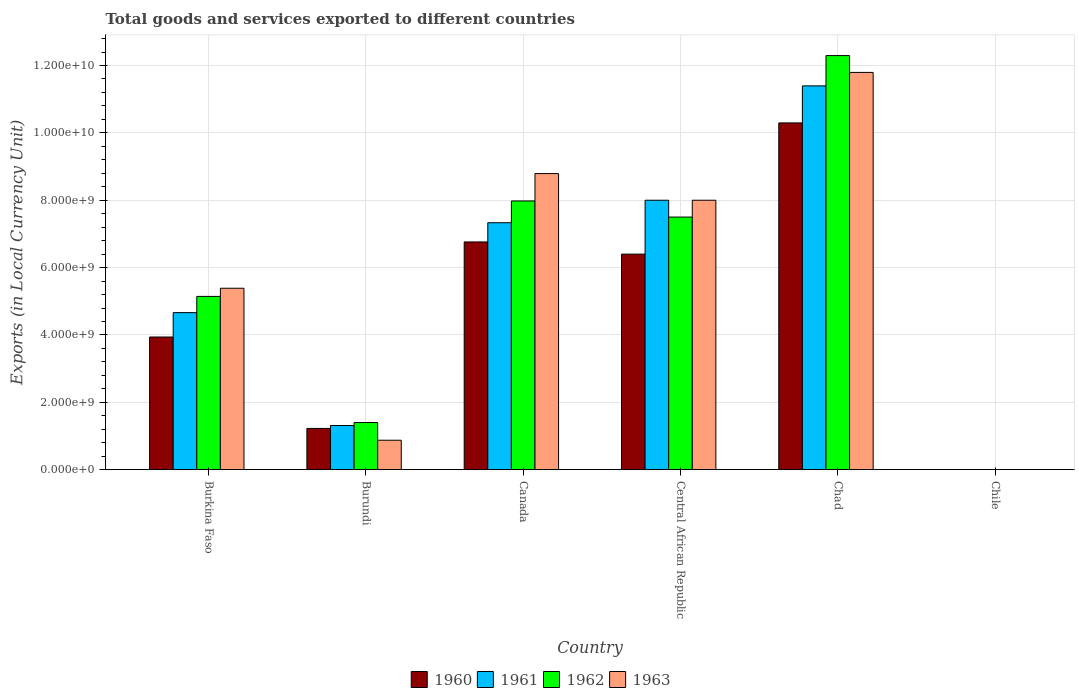How many groups of bars are there?
Provide a short and direct response. 6. Are the number of bars per tick equal to the number of legend labels?
Give a very brief answer. Yes. How many bars are there on the 1st tick from the left?
Offer a terse response. 4. What is the label of the 4th group of bars from the left?
Provide a succinct answer. Central African Republic. What is the Amount of goods and services exports in 1960 in Burundi?
Ensure brevity in your answer.  1.22e+09. Across all countries, what is the maximum Amount of goods and services exports in 1961?
Offer a very short reply. 1.14e+1. Across all countries, what is the minimum Amount of goods and services exports in 1962?
Your response must be concise. 7.00e+05. In which country was the Amount of goods and services exports in 1961 maximum?
Keep it short and to the point. Chad. What is the total Amount of goods and services exports in 1961 in the graph?
Offer a very short reply. 3.27e+1. What is the difference between the Amount of goods and services exports in 1963 in Burundi and that in Chad?
Your answer should be very brief. -1.09e+1. What is the difference between the Amount of goods and services exports in 1963 in Burkina Faso and the Amount of goods and services exports in 1961 in Central African Republic?
Offer a very short reply. -2.61e+09. What is the average Amount of goods and services exports in 1962 per country?
Your answer should be very brief. 5.72e+09. What is the difference between the Amount of goods and services exports of/in 1961 and Amount of goods and services exports of/in 1963 in Canada?
Offer a very short reply. -1.46e+09. What is the ratio of the Amount of goods and services exports in 1962 in Burundi to that in Central African Republic?
Make the answer very short. 0.19. Is the Amount of goods and services exports in 1963 in Central African Republic less than that in Chad?
Offer a terse response. Yes. Is the difference between the Amount of goods and services exports in 1961 in Burkina Faso and Burundi greater than the difference between the Amount of goods and services exports in 1963 in Burkina Faso and Burundi?
Give a very brief answer. No. What is the difference between the highest and the second highest Amount of goods and services exports in 1962?
Provide a short and direct response. 4.32e+09. What is the difference between the highest and the lowest Amount of goods and services exports in 1960?
Ensure brevity in your answer.  1.03e+1. In how many countries, is the Amount of goods and services exports in 1962 greater than the average Amount of goods and services exports in 1962 taken over all countries?
Provide a short and direct response. 3. What does the 3rd bar from the left in Canada represents?
Provide a succinct answer. 1962. Are all the bars in the graph horizontal?
Your answer should be compact. No. Are the values on the major ticks of Y-axis written in scientific E-notation?
Offer a very short reply. Yes. Does the graph contain any zero values?
Your answer should be very brief. No. Does the graph contain grids?
Your answer should be very brief. Yes. How are the legend labels stacked?
Make the answer very short. Horizontal. What is the title of the graph?
Make the answer very short. Total goods and services exported to different countries. Does "2003" appear as one of the legend labels in the graph?
Your answer should be very brief. No. What is the label or title of the X-axis?
Ensure brevity in your answer.  Country. What is the label or title of the Y-axis?
Offer a terse response. Exports (in Local Currency Unit). What is the Exports (in Local Currency Unit) in 1960 in Burkina Faso?
Offer a very short reply. 3.94e+09. What is the Exports (in Local Currency Unit) in 1961 in Burkina Faso?
Offer a terse response. 4.66e+09. What is the Exports (in Local Currency Unit) of 1962 in Burkina Faso?
Ensure brevity in your answer.  5.14e+09. What is the Exports (in Local Currency Unit) of 1963 in Burkina Faso?
Provide a succinct answer. 5.39e+09. What is the Exports (in Local Currency Unit) in 1960 in Burundi?
Provide a short and direct response. 1.22e+09. What is the Exports (in Local Currency Unit) of 1961 in Burundi?
Make the answer very short. 1.31e+09. What is the Exports (in Local Currency Unit) in 1962 in Burundi?
Offer a very short reply. 1.40e+09. What is the Exports (in Local Currency Unit) of 1963 in Burundi?
Provide a short and direct response. 8.75e+08. What is the Exports (in Local Currency Unit) in 1960 in Canada?
Your answer should be compact. 6.76e+09. What is the Exports (in Local Currency Unit) in 1961 in Canada?
Offer a very short reply. 7.33e+09. What is the Exports (in Local Currency Unit) in 1962 in Canada?
Your answer should be very brief. 7.98e+09. What is the Exports (in Local Currency Unit) of 1963 in Canada?
Give a very brief answer. 8.79e+09. What is the Exports (in Local Currency Unit) in 1960 in Central African Republic?
Ensure brevity in your answer.  6.40e+09. What is the Exports (in Local Currency Unit) in 1961 in Central African Republic?
Provide a succinct answer. 8.00e+09. What is the Exports (in Local Currency Unit) of 1962 in Central African Republic?
Your answer should be very brief. 7.50e+09. What is the Exports (in Local Currency Unit) in 1963 in Central African Republic?
Offer a terse response. 8.00e+09. What is the Exports (in Local Currency Unit) of 1960 in Chad?
Your answer should be very brief. 1.03e+1. What is the Exports (in Local Currency Unit) of 1961 in Chad?
Ensure brevity in your answer.  1.14e+1. What is the Exports (in Local Currency Unit) in 1962 in Chad?
Ensure brevity in your answer.  1.23e+1. What is the Exports (in Local Currency Unit) in 1963 in Chad?
Your response must be concise. 1.18e+1. What is the Exports (in Local Currency Unit) in 1961 in Chile?
Your answer should be very brief. 6.00e+05. What is the Exports (in Local Currency Unit) in 1962 in Chile?
Make the answer very short. 7.00e+05. What is the Exports (in Local Currency Unit) in 1963 in Chile?
Your answer should be compact. 1.10e+06. Across all countries, what is the maximum Exports (in Local Currency Unit) in 1960?
Ensure brevity in your answer.  1.03e+1. Across all countries, what is the maximum Exports (in Local Currency Unit) of 1961?
Ensure brevity in your answer.  1.14e+1. Across all countries, what is the maximum Exports (in Local Currency Unit) in 1962?
Offer a terse response. 1.23e+1. Across all countries, what is the maximum Exports (in Local Currency Unit) of 1963?
Offer a terse response. 1.18e+1. Across all countries, what is the minimum Exports (in Local Currency Unit) of 1960?
Give a very brief answer. 6.00e+05. Across all countries, what is the minimum Exports (in Local Currency Unit) in 1962?
Your answer should be very brief. 7.00e+05. Across all countries, what is the minimum Exports (in Local Currency Unit) of 1963?
Your answer should be compact. 1.10e+06. What is the total Exports (in Local Currency Unit) of 1960 in the graph?
Make the answer very short. 2.86e+1. What is the total Exports (in Local Currency Unit) of 1961 in the graph?
Give a very brief answer. 3.27e+1. What is the total Exports (in Local Currency Unit) in 1962 in the graph?
Keep it short and to the point. 3.43e+1. What is the total Exports (in Local Currency Unit) of 1963 in the graph?
Offer a terse response. 3.48e+1. What is the difference between the Exports (in Local Currency Unit) in 1960 in Burkina Faso and that in Burundi?
Give a very brief answer. 2.71e+09. What is the difference between the Exports (in Local Currency Unit) in 1961 in Burkina Faso and that in Burundi?
Ensure brevity in your answer.  3.35e+09. What is the difference between the Exports (in Local Currency Unit) in 1962 in Burkina Faso and that in Burundi?
Your response must be concise. 3.74e+09. What is the difference between the Exports (in Local Currency Unit) of 1963 in Burkina Faso and that in Burundi?
Your answer should be compact. 4.51e+09. What is the difference between the Exports (in Local Currency Unit) of 1960 in Burkina Faso and that in Canada?
Make the answer very short. -2.82e+09. What is the difference between the Exports (in Local Currency Unit) of 1961 in Burkina Faso and that in Canada?
Make the answer very short. -2.67e+09. What is the difference between the Exports (in Local Currency Unit) of 1962 in Burkina Faso and that in Canada?
Make the answer very short. -2.83e+09. What is the difference between the Exports (in Local Currency Unit) in 1963 in Burkina Faso and that in Canada?
Ensure brevity in your answer.  -3.40e+09. What is the difference between the Exports (in Local Currency Unit) in 1960 in Burkina Faso and that in Central African Republic?
Make the answer very short. -2.46e+09. What is the difference between the Exports (in Local Currency Unit) of 1961 in Burkina Faso and that in Central African Republic?
Your response must be concise. -3.34e+09. What is the difference between the Exports (in Local Currency Unit) of 1962 in Burkina Faso and that in Central African Republic?
Keep it short and to the point. -2.36e+09. What is the difference between the Exports (in Local Currency Unit) of 1963 in Burkina Faso and that in Central African Republic?
Your answer should be very brief. -2.61e+09. What is the difference between the Exports (in Local Currency Unit) in 1960 in Burkina Faso and that in Chad?
Your response must be concise. -6.36e+09. What is the difference between the Exports (in Local Currency Unit) in 1961 in Burkina Faso and that in Chad?
Provide a short and direct response. -6.73e+09. What is the difference between the Exports (in Local Currency Unit) in 1962 in Burkina Faso and that in Chad?
Your answer should be compact. -7.15e+09. What is the difference between the Exports (in Local Currency Unit) of 1963 in Burkina Faso and that in Chad?
Give a very brief answer. -6.41e+09. What is the difference between the Exports (in Local Currency Unit) of 1960 in Burkina Faso and that in Chile?
Offer a terse response. 3.94e+09. What is the difference between the Exports (in Local Currency Unit) in 1961 in Burkina Faso and that in Chile?
Provide a short and direct response. 4.66e+09. What is the difference between the Exports (in Local Currency Unit) in 1962 in Burkina Faso and that in Chile?
Offer a terse response. 5.14e+09. What is the difference between the Exports (in Local Currency Unit) of 1963 in Burkina Faso and that in Chile?
Give a very brief answer. 5.39e+09. What is the difference between the Exports (in Local Currency Unit) in 1960 in Burundi and that in Canada?
Keep it short and to the point. -5.54e+09. What is the difference between the Exports (in Local Currency Unit) of 1961 in Burundi and that in Canada?
Your response must be concise. -6.02e+09. What is the difference between the Exports (in Local Currency Unit) in 1962 in Burundi and that in Canada?
Your answer should be very brief. -6.58e+09. What is the difference between the Exports (in Local Currency Unit) in 1963 in Burundi and that in Canada?
Provide a succinct answer. -7.92e+09. What is the difference between the Exports (in Local Currency Unit) in 1960 in Burundi and that in Central African Republic?
Give a very brief answer. -5.18e+09. What is the difference between the Exports (in Local Currency Unit) of 1961 in Burundi and that in Central African Republic?
Keep it short and to the point. -6.69e+09. What is the difference between the Exports (in Local Currency Unit) of 1962 in Burundi and that in Central African Republic?
Provide a short and direct response. -6.10e+09. What is the difference between the Exports (in Local Currency Unit) in 1963 in Burundi and that in Central African Republic?
Ensure brevity in your answer.  -7.12e+09. What is the difference between the Exports (in Local Currency Unit) of 1960 in Burundi and that in Chad?
Your answer should be compact. -9.07e+09. What is the difference between the Exports (in Local Currency Unit) in 1961 in Burundi and that in Chad?
Offer a terse response. -1.01e+1. What is the difference between the Exports (in Local Currency Unit) of 1962 in Burundi and that in Chad?
Ensure brevity in your answer.  -1.09e+1. What is the difference between the Exports (in Local Currency Unit) of 1963 in Burundi and that in Chad?
Provide a succinct answer. -1.09e+1. What is the difference between the Exports (in Local Currency Unit) in 1960 in Burundi and that in Chile?
Keep it short and to the point. 1.22e+09. What is the difference between the Exports (in Local Currency Unit) of 1961 in Burundi and that in Chile?
Your answer should be very brief. 1.31e+09. What is the difference between the Exports (in Local Currency Unit) in 1962 in Burundi and that in Chile?
Make the answer very short. 1.40e+09. What is the difference between the Exports (in Local Currency Unit) in 1963 in Burundi and that in Chile?
Make the answer very short. 8.74e+08. What is the difference between the Exports (in Local Currency Unit) of 1960 in Canada and that in Central African Republic?
Give a very brief answer. 3.61e+08. What is the difference between the Exports (in Local Currency Unit) of 1961 in Canada and that in Central African Republic?
Your answer should be compact. -6.68e+08. What is the difference between the Exports (in Local Currency Unit) of 1962 in Canada and that in Central African Republic?
Give a very brief answer. 4.78e+08. What is the difference between the Exports (in Local Currency Unit) in 1963 in Canada and that in Central African Republic?
Offer a very short reply. 7.91e+08. What is the difference between the Exports (in Local Currency Unit) in 1960 in Canada and that in Chad?
Your answer should be very brief. -3.53e+09. What is the difference between the Exports (in Local Currency Unit) of 1961 in Canada and that in Chad?
Make the answer very short. -4.06e+09. What is the difference between the Exports (in Local Currency Unit) of 1962 in Canada and that in Chad?
Give a very brief answer. -4.32e+09. What is the difference between the Exports (in Local Currency Unit) in 1963 in Canada and that in Chad?
Provide a short and direct response. -3.00e+09. What is the difference between the Exports (in Local Currency Unit) in 1960 in Canada and that in Chile?
Offer a very short reply. 6.76e+09. What is the difference between the Exports (in Local Currency Unit) in 1961 in Canada and that in Chile?
Ensure brevity in your answer.  7.33e+09. What is the difference between the Exports (in Local Currency Unit) of 1962 in Canada and that in Chile?
Provide a short and direct response. 7.98e+09. What is the difference between the Exports (in Local Currency Unit) of 1963 in Canada and that in Chile?
Your answer should be very brief. 8.79e+09. What is the difference between the Exports (in Local Currency Unit) of 1960 in Central African Republic and that in Chad?
Give a very brief answer. -3.90e+09. What is the difference between the Exports (in Local Currency Unit) in 1961 in Central African Republic and that in Chad?
Offer a terse response. -3.39e+09. What is the difference between the Exports (in Local Currency Unit) of 1962 in Central African Republic and that in Chad?
Make the answer very short. -4.79e+09. What is the difference between the Exports (in Local Currency Unit) in 1963 in Central African Republic and that in Chad?
Your answer should be very brief. -3.79e+09. What is the difference between the Exports (in Local Currency Unit) in 1960 in Central African Republic and that in Chile?
Provide a short and direct response. 6.40e+09. What is the difference between the Exports (in Local Currency Unit) of 1961 in Central African Republic and that in Chile?
Ensure brevity in your answer.  8.00e+09. What is the difference between the Exports (in Local Currency Unit) of 1962 in Central African Republic and that in Chile?
Your response must be concise. 7.50e+09. What is the difference between the Exports (in Local Currency Unit) of 1963 in Central African Republic and that in Chile?
Keep it short and to the point. 8.00e+09. What is the difference between the Exports (in Local Currency Unit) of 1960 in Chad and that in Chile?
Make the answer very short. 1.03e+1. What is the difference between the Exports (in Local Currency Unit) of 1961 in Chad and that in Chile?
Your answer should be compact. 1.14e+1. What is the difference between the Exports (in Local Currency Unit) of 1962 in Chad and that in Chile?
Your answer should be compact. 1.23e+1. What is the difference between the Exports (in Local Currency Unit) of 1963 in Chad and that in Chile?
Your response must be concise. 1.18e+1. What is the difference between the Exports (in Local Currency Unit) of 1960 in Burkina Faso and the Exports (in Local Currency Unit) of 1961 in Burundi?
Make the answer very short. 2.63e+09. What is the difference between the Exports (in Local Currency Unit) of 1960 in Burkina Faso and the Exports (in Local Currency Unit) of 1962 in Burundi?
Your answer should be very brief. 2.54e+09. What is the difference between the Exports (in Local Currency Unit) of 1960 in Burkina Faso and the Exports (in Local Currency Unit) of 1963 in Burundi?
Make the answer very short. 3.06e+09. What is the difference between the Exports (in Local Currency Unit) in 1961 in Burkina Faso and the Exports (in Local Currency Unit) in 1962 in Burundi?
Ensure brevity in your answer.  3.26e+09. What is the difference between the Exports (in Local Currency Unit) of 1961 in Burkina Faso and the Exports (in Local Currency Unit) of 1963 in Burundi?
Make the answer very short. 3.79e+09. What is the difference between the Exports (in Local Currency Unit) in 1962 in Burkina Faso and the Exports (in Local Currency Unit) in 1963 in Burundi?
Your answer should be very brief. 4.27e+09. What is the difference between the Exports (in Local Currency Unit) of 1960 in Burkina Faso and the Exports (in Local Currency Unit) of 1961 in Canada?
Your answer should be compact. -3.39e+09. What is the difference between the Exports (in Local Currency Unit) of 1960 in Burkina Faso and the Exports (in Local Currency Unit) of 1962 in Canada?
Make the answer very short. -4.04e+09. What is the difference between the Exports (in Local Currency Unit) in 1960 in Burkina Faso and the Exports (in Local Currency Unit) in 1963 in Canada?
Offer a very short reply. -4.85e+09. What is the difference between the Exports (in Local Currency Unit) in 1961 in Burkina Faso and the Exports (in Local Currency Unit) in 1962 in Canada?
Provide a succinct answer. -3.31e+09. What is the difference between the Exports (in Local Currency Unit) of 1961 in Burkina Faso and the Exports (in Local Currency Unit) of 1963 in Canada?
Provide a short and direct response. -4.13e+09. What is the difference between the Exports (in Local Currency Unit) of 1962 in Burkina Faso and the Exports (in Local Currency Unit) of 1963 in Canada?
Offer a very short reply. -3.65e+09. What is the difference between the Exports (in Local Currency Unit) of 1960 in Burkina Faso and the Exports (in Local Currency Unit) of 1961 in Central African Republic?
Make the answer very short. -4.06e+09. What is the difference between the Exports (in Local Currency Unit) in 1960 in Burkina Faso and the Exports (in Local Currency Unit) in 1962 in Central African Republic?
Your response must be concise. -3.56e+09. What is the difference between the Exports (in Local Currency Unit) in 1960 in Burkina Faso and the Exports (in Local Currency Unit) in 1963 in Central African Republic?
Make the answer very short. -4.06e+09. What is the difference between the Exports (in Local Currency Unit) of 1961 in Burkina Faso and the Exports (in Local Currency Unit) of 1962 in Central African Republic?
Your answer should be compact. -2.84e+09. What is the difference between the Exports (in Local Currency Unit) of 1961 in Burkina Faso and the Exports (in Local Currency Unit) of 1963 in Central African Republic?
Your answer should be compact. -3.34e+09. What is the difference between the Exports (in Local Currency Unit) in 1962 in Burkina Faso and the Exports (in Local Currency Unit) in 1963 in Central African Republic?
Your answer should be compact. -2.86e+09. What is the difference between the Exports (in Local Currency Unit) of 1960 in Burkina Faso and the Exports (in Local Currency Unit) of 1961 in Chad?
Provide a short and direct response. -7.46e+09. What is the difference between the Exports (in Local Currency Unit) in 1960 in Burkina Faso and the Exports (in Local Currency Unit) in 1962 in Chad?
Your response must be concise. -8.35e+09. What is the difference between the Exports (in Local Currency Unit) in 1960 in Burkina Faso and the Exports (in Local Currency Unit) in 1963 in Chad?
Your answer should be very brief. -7.86e+09. What is the difference between the Exports (in Local Currency Unit) of 1961 in Burkina Faso and the Exports (in Local Currency Unit) of 1962 in Chad?
Give a very brief answer. -7.63e+09. What is the difference between the Exports (in Local Currency Unit) of 1961 in Burkina Faso and the Exports (in Local Currency Unit) of 1963 in Chad?
Offer a terse response. -7.13e+09. What is the difference between the Exports (in Local Currency Unit) in 1962 in Burkina Faso and the Exports (in Local Currency Unit) in 1963 in Chad?
Provide a short and direct response. -6.65e+09. What is the difference between the Exports (in Local Currency Unit) in 1960 in Burkina Faso and the Exports (in Local Currency Unit) in 1961 in Chile?
Offer a very short reply. 3.94e+09. What is the difference between the Exports (in Local Currency Unit) in 1960 in Burkina Faso and the Exports (in Local Currency Unit) in 1962 in Chile?
Give a very brief answer. 3.94e+09. What is the difference between the Exports (in Local Currency Unit) in 1960 in Burkina Faso and the Exports (in Local Currency Unit) in 1963 in Chile?
Keep it short and to the point. 3.94e+09. What is the difference between the Exports (in Local Currency Unit) of 1961 in Burkina Faso and the Exports (in Local Currency Unit) of 1962 in Chile?
Provide a succinct answer. 4.66e+09. What is the difference between the Exports (in Local Currency Unit) in 1961 in Burkina Faso and the Exports (in Local Currency Unit) in 1963 in Chile?
Ensure brevity in your answer.  4.66e+09. What is the difference between the Exports (in Local Currency Unit) of 1962 in Burkina Faso and the Exports (in Local Currency Unit) of 1963 in Chile?
Give a very brief answer. 5.14e+09. What is the difference between the Exports (in Local Currency Unit) of 1960 in Burundi and the Exports (in Local Currency Unit) of 1961 in Canada?
Give a very brief answer. -6.11e+09. What is the difference between the Exports (in Local Currency Unit) in 1960 in Burundi and the Exports (in Local Currency Unit) in 1962 in Canada?
Provide a succinct answer. -6.75e+09. What is the difference between the Exports (in Local Currency Unit) of 1960 in Burundi and the Exports (in Local Currency Unit) of 1963 in Canada?
Ensure brevity in your answer.  -7.57e+09. What is the difference between the Exports (in Local Currency Unit) of 1961 in Burundi and the Exports (in Local Currency Unit) of 1962 in Canada?
Offer a very short reply. -6.67e+09. What is the difference between the Exports (in Local Currency Unit) of 1961 in Burundi and the Exports (in Local Currency Unit) of 1963 in Canada?
Your answer should be compact. -7.48e+09. What is the difference between the Exports (in Local Currency Unit) in 1962 in Burundi and the Exports (in Local Currency Unit) in 1963 in Canada?
Offer a terse response. -7.39e+09. What is the difference between the Exports (in Local Currency Unit) of 1960 in Burundi and the Exports (in Local Currency Unit) of 1961 in Central African Republic?
Make the answer very short. -6.78e+09. What is the difference between the Exports (in Local Currency Unit) in 1960 in Burundi and the Exports (in Local Currency Unit) in 1962 in Central African Republic?
Provide a short and direct response. -6.28e+09. What is the difference between the Exports (in Local Currency Unit) of 1960 in Burundi and the Exports (in Local Currency Unit) of 1963 in Central African Republic?
Your answer should be compact. -6.78e+09. What is the difference between the Exports (in Local Currency Unit) of 1961 in Burundi and the Exports (in Local Currency Unit) of 1962 in Central African Republic?
Your response must be concise. -6.19e+09. What is the difference between the Exports (in Local Currency Unit) in 1961 in Burundi and the Exports (in Local Currency Unit) in 1963 in Central African Republic?
Offer a very short reply. -6.69e+09. What is the difference between the Exports (in Local Currency Unit) in 1962 in Burundi and the Exports (in Local Currency Unit) in 1963 in Central African Republic?
Provide a succinct answer. -6.60e+09. What is the difference between the Exports (in Local Currency Unit) of 1960 in Burundi and the Exports (in Local Currency Unit) of 1961 in Chad?
Give a very brief answer. -1.02e+1. What is the difference between the Exports (in Local Currency Unit) of 1960 in Burundi and the Exports (in Local Currency Unit) of 1962 in Chad?
Your answer should be compact. -1.11e+1. What is the difference between the Exports (in Local Currency Unit) in 1960 in Burundi and the Exports (in Local Currency Unit) in 1963 in Chad?
Provide a succinct answer. -1.06e+1. What is the difference between the Exports (in Local Currency Unit) of 1961 in Burundi and the Exports (in Local Currency Unit) of 1962 in Chad?
Offer a terse response. -1.10e+1. What is the difference between the Exports (in Local Currency Unit) in 1961 in Burundi and the Exports (in Local Currency Unit) in 1963 in Chad?
Ensure brevity in your answer.  -1.05e+1. What is the difference between the Exports (in Local Currency Unit) of 1962 in Burundi and the Exports (in Local Currency Unit) of 1963 in Chad?
Make the answer very short. -1.04e+1. What is the difference between the Exports (in Local Currency Unit) in 1960 in Burundi and the Exports (in Local Currency Unit) in 1961 in Chile?
Offer a very short reply. 1.22e+09. What is the difference between the Exports (in Local Currency Unit) of 1960 in Burundi and the Exports (in Local Currency Unit) of 1962 in Chile?
Keep it short and to the point. 1.22e+09. What is the difference between the Exports (in Local Currency Unit) of 1960 in Burundi and the Exports (in Local Currency Unit) of 1963 in Chile?
Make the answer very short. 1.22e+09. What is the difference between the Exports (in Local Currency Unit) of 1961 in Burundi and the Exports (in Local Currency Unit) of 1962 in Chile?
Keep it short and to the point. 1.31e+09. What is the difference between the Exports (in Local Currency Unit) of 1961 in Burundi and the Exports (in Local Currency Unit) of 1963 in Chile?
Your answer should be compact. 1.31e+09. What is the difference between the Exports (in Local Currency Unit) of 1962 in Burundi and the Exports (in Local Currency Unit) of 1963 in Chile?
Make the answer very short. 1.40e+09. What is the difference between the Exports (in Local Currency Unit) of 1960 in Canada and the Exports (in Local Currency Unit) of 1961 in Central African Republic?
Your answer should be very brief. -1.24e+09. What is the difference between the Exports (in Local Currency Unit) of 1960 in Canada and the Exports (in Local Currency Unit) of 1962 in Central African Republic?
Provide a short and direct response. -7.39e+08. What is the difference between the Exports (in Local Currency Unit) in 1960 in Canada and the Exports (in Local Currency Unit) in 1963 in Central African Republic?
Provide a short and direct response. -1.24e+09. What is the difference between the Exports (in Local Currency Unit) of 1961 in Canada and the Exports (in Local Currency Unit) of 1962 in Central African Republic?
Give a very brief answer. -1.68e+08. What is the difference between the Exports (in Local Currency Unit) in 1961 in Canada and the Exports (in Local Currency Unit) in 1963 in Central African Republic?
Provide a short and direct response. -6.68e+08. What is the difference between the Exports (in Local Currency Unit) of 1962 in Canada and the Exports (in Local Currency Unit) of 1963 in Central African Republic?
Provide a short and direct response. -2.17e+07. What is the difference between the Exports (in Local Currency Unit) in 1960 in Canada and the Exports (in Local Currency Unit) in 1961 in Chad?
Keep it short and to the point. -4.63e+09. What is the difference between the Exports (in Local Currency Unit) of 1960 in Canada and the Exports (in Local Currency Unit) of 1962 in Chad?
Provide a succinct answer. -5.53e+09. What is the difference between the Exports (in Local Currency Unit) in 1960 in Canada and the Exports (in Local Currency Unit) in 1963 in Chad?
Your response must be concise. -5.03e+09. What is the difference between the Exports (in Local Currency Unit) of 1961 in Canada and the Exports (in Local Currency Unit) of 1962 in Chad?
Your answer should be very brief. -4.96e+09. What is the difference between the Exports (in Local Currency Unit) in 1961 in Canada and the Exports (in Local Currency Unit) in 1963 in Chad?
Keep it short and to the point. -4.46e+09. What is the difference between the Exports (in Local Currency Unit) in 1962 in Canada and the Exports (in Local Currency Unit) in 1963 in Chad?
Make the answer very short. -3.82e+09. What is the difference between the Exports (in Local Currency Unit) of 1960 in Canada and the Exports (in Local Currency Unit) of 1961 in Chile?
Provide a succinct answer. 6.76e+09. What is the difference between the Exports (in Local Currency Unit) of 1960 in Canada and the Exports (in Local Currency Unit) of 1962 in Chile?
Give a very brief answer. 6.76e+09. What is the difference between the Exports (in Local Currency Unit) in 1960 in Canada and the Exports (in Local Currency Unit) in 1963 in Chile?
Offer a terse response. 6.76e+09. What is the difference between the Exports (in Local Currency Unit) of 1961 in Canada and the Exports (in Local Currency Unit) of 1962 in Chile?
Your answer should be very brief. 7.33e+09. What is the difference between the Exports (in Local Currency Unit) of 1961 in Canada and the Exports (in Local Currency Unit) of 1963 in Chile?
Your answer should be compact. 7.33e+09. What is the difference between the Exports (in Local Currency Unit) of 1962 in Canada and the Exports (in Local Currency Unit) of 1963 in Chile?
Keep it short and to the point. 7.98e+09. What is the difference between the Exports (in Local Currency Unit) of 1960 in Central African Republic and the Exports (in Local Currency Unit) of 1961 in Chad?
Keep it short and to the point. -4.99e+09. What is the difference between the Exports (in Local Currency Unit) in 1960 in Central African Republic and the Exports (in Local Currency Unit) in 1962 in Chad?
Offer a terse response. -5.89e+09. What is the difference between the Exports (in Local Currency Unit) in 1960 in Central African Republic and the Exports (in Local Currency Unit) in 1963 in Chad?
Your response must be concise. -5.39e+09. What is the difference between the Exports (in Local Currency Unit) of 1961 in Central African Republic and the Exports (in Local Currency Unit) of 1962 in Chad?
Offer a terse response. -4.29e+09. What is the difference between the Exports (in Local Currency Unit) of 1961 in Central African Republic and the Exports (in Local Currency Unit) of 1963 in Chad?
Offer a very short reply. -3.79e+09. What is the difference between the Exports (in Local Currency Unit) in 1962 in Central African Republic and the Exports (in Local Currency Unit) in 1963 in Chad?
Offer a terse response. -4.29e+09. What is the difference between the Exports (in Local Currency Unit) of 1960 in Central African Republic and the Exports (in Local Currency Unit) of 1961 in Chile?
Give a very brief answer. 6.40e+09. What is the difference between the Exports (in Local Currency Unit) of 1960 in Central African Republic and the Exports (in Local Currency Unit) of 1962 in Chile?
Keep it short and to the point. 6.40e+09. What is the difference between the Exports (in Local Currency Unit) in 1960 in Central African Republic and the Exports (in Local Currency Unit) in 1963 in Chile?
Make the answer very short. 6.40e+09. What is the difference between the Exports (in Local Currency Unit) of 1961 in Central African Republic and the Exports (in Local Currency Unit) of 1962 in Chile?
Provide a succinct answer. 8.00e+09. What is the difference between the Exports (in Local Currency Unit) of 1961 in Central African Republic and the Exports (in Local Currency Unit) of 1963 in Chile?
Your answer should be compact. 8.00e+09. What is the difference between the Exports (in Local Currency Unit) of 1962 in Central African Republic and the Exports (in Local Currency Unit) of 1963 in Chile?
Offer a terse response. 7.50e+09. What is the difference between the Exports (in Local Currency Unit) of 1960 in Chad and the Exports (in Local Currency Unit) of 1961 in Chile?
Provide a short and direct response. 1.03e+1. What is the difference between the Exports (in Local Currency Unit) of 1960 in Chad and the Exports (in Local Currency Unit) of 1962 in Chile?
Your answer should be very brief. 1.03e+1. What is the difference between the Exports (in Local Currency Unit) in 1960 in Chad and the Exports (in Local Currency Unit) in 1963 in Chile?
Ensure brevity in your answer.  1.03e+1. What is the difference between the Exports (in Local Currency Unit) in 1961 in Chad and the Exports (in Local Currency Unit) in 1962 in Chile?
Offer a very short reply. 1.14e+1. What is the difference between the Exports (in Local Currency Unit) in 1961 in Chad and the Exports (in Local Currency Unit) in 1963 in Chile?
Provide a succinct answer. 1.14e+1. What is the difference between the Exports (in Local Currency Unit) of 1962 in Chad and the Exports (in Local Currency Unit) of 1963 in Chile?
Keep it short and to the point. 1.23e+1. What is the average Exports (in Local Currency Unit) of 1960 per country?
Offer a terse response. 4.77e+09. What is the average Exports (in Local Currency Unit) in 1961 per country?
Your answer should be very brief. 5.45e+09. What is the average Exports (in Local Currency Unit) of 1962 per country?
Your response must be concise. 5.72e+09. What is the average Exports (in Local Currency Unit) of 1963 per country?
Your response must be concise. 5.81e+09. What is the difference between the Exports (in Local Currency Unit) in 1960 and Exports (in Local Currency Unit) in 1961 in Burkina Faso?
Provide a short and direct response. -7.24e+08. What is the difference between the Exports (in Local Currency Unit) of 1960 and Exports (in Local Currency Unit) of 1962 in Burkina Faso?
Keep it short and to the point. -1.21e+09. What is the difference between the Exports (in Local Currency Unit) in 1960 and Exports (in Local Currency Unit) in 1963 in Burkina Faso?
Your answer should be very brief. -1.45e+09. What is the difference between the Exports (in Local Currency Unit) of 1961 and Exports (in Local Currency Unit) of 1962 in Burkina Faso?
Offer a terse response. -4.81e+08. What is the difference between the Exports (in Local Currency Unit) in 1961 and Exports (in Local Currency Unit) in 1963 in Burkina Faso?
Ensure brevity in your answer.  -7.23e+08. What is the difference between the Exports (in Local Currency Unit) in 1962 and Exports (in Local Currency Unit) in 1963 in Burkina Faso?
Your answer should be compact. -2.42e+08. What is the difference between the Exports (in Local Currency Unit) of 1960 and Exports (in Local Currency Unit) of 1961 in Burundi?
Ensure brevity in your answer.  -8.75e+07. What is the difference between the Exports (in Local Currency Unit) in 1960 and Exports (in Local Currency Unit) in 1962 in Burundi?
Give a very brief answer. -1.75e+08. What is the difference between the Exports (in Local Currency Unit) of 1960 and Exports (in Local Currency Unit) of 1963 in Burundi?
Your answer should be very brief. 3.50e+08. What is the difference between the Exports (in Local Currency Unit) of 1961 and Exports (in Local Currency Unit) of 1962 in Burundi?
Offer a terse response. -8.75e+07. What is the difference between the Exports (in Local Currency Unit) of 1961 and Exports (in Local Currency Unit) of 1963 in Burundi?
Offer a very short reply. 4.38e+08. What is the difference between the Exports (in Local Currency Unit) of 1962 and Exports (in Local Currency Unit) of 1963 in Burundi?
Make the answer very short. 5.25e+08. What is the difference between the Exports (in Local Currency Unit) in 1960 and Exports (in Local Currency Unit) in 1961 in Canada?
Your answer should be compact. -5.71e+08. What is the difference between the Exports (in Local Currency Unit) of 1960 and Exports (in Local Currency Unit) of 1962 in Canada?
Offer a terse response. -1.22e+09. What is the difference between the Exports (in Local Currency Unit) in 1960 and Exports (in Local Currency Unit) in 1963 in Canada?
Keep it short and to the point. -2.03e+09. What is the difference between the Exports (in Local Currency Unit) in 1961 and Exports (in Local Currency Unit) in 1962 in Canada?
Your answer should be compact. -6.46e+08. What is the difference between the Exports (in Local Currency Unit) of 1961 and Exports (in Local Currency Unit) of 1963 in Canada?
Offer a very short reply. -1.46e+09. What is the difference between the Exports (in Local Currency Unit) of 1962 and Exports (in Local Currency Unit) of 1963 in Canada?
Make the answer very short. -8.13e+08. What is the difference between the Exports (in Local Currency Unit) of 1960 and Exports (in Local Currency Unit) of 1961 in Central African Republic?
Make the answer very short. -1.60e+09. What is the difference between the Exports (in Local Currency Unit) in 1960 and Exports (in Local Currency Unit) in 1962 in Central African Republic?
Your answer should be very brief. -1.10e+09. What is the difference between the Exports (in Local Currency Unit) in 1960 and Exports (in Local Currency Unit) in 1963 in Central African Republic?
Provide a short and direct response. -1.60e+09. What is the difference between the Exports (in Local Currency Unit) in 1961 and Exports (in Local Currency Unit) in 1962 in Central African Republic?
Ensure brevity in your answer.  5.00e+08. What is the difference between the Exports (in Local Currency Unit) in 1961 and Exports (in Local Currency Unit) in 1963 in Central African Republic?
Provide a succinct answer. 0. What is the difference between the Exports (in Local Currency Unit) in 1962 and Exports (in Local Currency Unit) in 1963 in Central African Republic?
Keep it short and to the point. -5.00e+08. What is the difference between the Exports (in Local Currency Unit) of 1960 and Exports (in Local Currency Unit) of 1961 in Chad?
Your response must be concise. -1.10e+09. What is the difference between the Exports (in Local Currency Unit) of 1960 and Exports (in Local Currency Unit) of 1962 in Chad?
Make the answer very short. -2.00e+09. What is the difference between the Exports (in Local Currency Unit) in 1960 and Exports (in Local Currency Unit) in 1963 in Chad?
Provide a short and direct response. -1.50e+09. What is the difference between the Exports (in Local Currency Unit) in 1961 and Exports (in Local Currency Unit) in 1962 in Chad?
Keep it short and to the point. -9.00e+08. What is the difference between the Exports (in Local Currency Unit) in 1961 and Exports (in Local Currency Unit) in 1963 in Chad?
Your answer should be very brief. -4.00e+08. What is the difference between the Exports (in Local Currency Unit) in 1962 and Exports (in Local Currency Unit) in 1963 in Chad?
Ensure brevity in your answer.  5.00e+08. What is the difference between the Exports (in Local Currency Unit) of 1960 and Exports (in Local Currency Unit) of 1961 in Chile?
Your answer should be very brief. 0. What is the difference between the Exports (in Local Currency Unit) in 1960 and Exports (in Local Currency Unit) in 1963 in Chile?
Provide a short and direct response. -5.00e+05. What is the difference between the Exports (in Local Currency Unit) in 1961 and Exports (in Local Currency Unit) in 1963 in Chile?
Your response must be concise. -5.00e+05. What is the difference between the Exports (in Local Currency Unit) of 1962 and Exports (in Local Currency Unit) of 1963 in Chile?
Provide a succinct answer. -4.00e+05. What is the ratio of the Exports (in Local Currency Unit) in 1960 in Burkina Faso to that in Burundi?
Give a very brief answer. 3.22. What is the ratio of the Exports (in Local Currency Unit) in 1961 in Burkina Faso to that in Burundi?
Make the answer very short. 3.55. What is the ratio of the Exports (in Local Currency Unit) in 1962 in Burkina Faso to that in Burundi?
Your answer should be compact. 3.67. What is the ratio of the Exports (in Local Currency Unit) in 1963 in Burkina Faso to that in Burundi?
Give a very brief answer. 6.16. What is the ratio of the Exports (in Local Currency Unit) of 1960 in Burkina Faso to that in Canada?
Offer a terse response. 0.58. What is the ratio of the Exports (in Local Currency Unit) in 1961 in Burkina Faso to that in Canada?
Your answer should be very brief. 0.64. What is the ratio of the Exports (in Local Currency Unit) in 1962 in Burkina Faso to that in Canada?
Your answer should be compact. 0.64. What is the ratio of the Exports (in Local Currency Unit) of 1963 in Burkina Faso to that in Canada?
Provide a succinct answer. 0.61. What is the ratio of the Exports (in Local Currency Unit) of 1960 in Burkina Faso to that in Central African Republic?
Your response must be concise. 0.62. What is the ratio of the Exports (in Local Currency Unit) of 1961 in Burkina Faso to that in Central African Republic?
Provide a succinct answer. 0.58. What is the ratio of the Exports (in Local Currency Unit) in 1962 in Burkina Faso to that in Central African Republic?
Ensure brevity in your answer.  0.69. What is the ratio of the Exports (in Local Currency Unit) of 1963 in Burkina Faso to that in Central African Republic?
Ensure brevity in your answer.  0.67. What is the ratio of the Exports (in Local Currency Unit) of 1960 in Burkina Faso to that in Chad?
Offer a very short reply. 0.38. What is the ratio of the Exports (in Local Currency Unit) of 1961 in Burkina Faso to that in Chad?
Keep it short and to the point. 0.41. What is the ratio of the Exports (in Local Currency Unit) of 1962 in Burkina Faso to that in Chad?
Ensure brevity in your answer.  0.42. What is the ratio of the Exports (in Local Currency Unit) of 1963 in Burkina Faso to that in Chad?
Make the answer very short. 0.46. What is the ratio of the Exports (in Local Currency Unit) in 1960 in Burkina Faso to that in Chile?
Give a very brief answer. 6565.51. What is the ratio of the Exports (in Local Currency Unit) of 1961 in Burkina Faso to that in Chile?
Ensure brevity in your answer.  7772.51. What is the ratio of the Exports (in Local Currency Unit) of 1962 in Burkina Faso to that in Chile?
Provide a short and direct response. 7349.57. What is the ratio of the Exports (in Local Currency Unit) in 1963 in Burkina Faso to that in Chile?
Offer a very short reply. 4897.09. What is the ratio of the Exports (in Local Currency Unit) in 1960 in Burundi to that in Canada?
Make the answer very short. 0.18. What is the ratio of the Exports (in Local Currency Unit) in 1961 in Burundi to that in Canada?
Offer a terse response. 0.18. What is the ratio of the Exports (in Local Currency Unit) of 1962 in Burundi to that in Canada?
Keep it short and to the point. 0.18. What is the ratio of the Exports (in Local Currency Unit) of 1963 in Burundi to that in Canada?
Your response must be concise. 0.1. What is the ratio of the Exports (in Local Currency Unit) in 1960 in Burundi to that in Central African Republic?
Make the answer very short. 0.19. What is the ratio of the Exports (in Local Currency Unit) in 1961 in Burundi to that in Central African Republic?
Ensure brevity in your answer.  0.16. What is the ratio of the Exports (in Local Currency Unit) of 1962 in Burundi to that in Central African Republic?
Your answer should be very brief. 0.19. What is the ratio of the Exports (in Local Currency Unit) of 1963 in Burundi to that in Central African Republic?
Give a very brief answer. 0.11. What is the ratio of the Exports (in Local Currency Unit) in 1960 in Burundi to that in Chad?
Give a very brief answer. 0.12. What is the ratio of the Exports (in Local Currency Unit) of 1961 in Burundi to that in Chad?
Your answer should be very brief. 0.12. What is the ratio of the Exports (in Local Currency Unit) of 1962 in Burundi to that in Chad?
Offer a very short reply. 0.11. What is the ratio of the Exports (in Local Currency Unit) in 1963 in Burundi to that in Chad?
Provide a short and direct response. 0.07. What is the ratio of the Exports (in Local Currency Unit) of 1960 in Burundi to that in Chile?
Give a very brief answer. 2041.67. What is the ratio of the Exports (in Local Currency Unit) of 1961 in Burundi to that in Chile?
Make the answer very short. 2187.5. What is the ratio of the Exports (in Local Currency Unit) in 1962 in Burundi to that in Chile?
Make the answer very short. 2000. What is the ratio of the Exports (in Local Currency Unit) in 1963 in Burundi to that in Chile?
Give a very brief answer. 795.45. What is the ratio of the Exports (in Local Currency Unit) of 1960 in Canada to that in Central African Republic?
Provide a short and direct response. 1.06. What is the ratio of the Exports (in Local Currency Unit) in 1961 in Canada to that in Central African Republic?
Give a very brief answer. 0.92. What is the ratio of the Exports (in Local Currency Unit) of 1962 in Canada to that in Central African Republic?
Keep it short and to the point. 1.06. What is the ratio of the Exports (in Local Currency Unit) of 1963 in Canada to that in Central African Republic?
Offer a terse response. 1.1. What is the ratio of the Exports (in Local Currency Unit) of 1960 in Canada to that in Chad?
Your answer should be very brief. 0.66. What is the ratio of the Exports (in Local Currency Unit) of 1961 in Canada to that in Chad?
Your answer should be compact. 0.64. What is the ratio of the Exports (in Local Currency Unit) in 1962 in Canada to that in Chad?
Offer a very short reply. 0.65. What is the ratio of the Exports (in Local Currency Unit) of 1963 in Canada to that in Chad?
Provide a succinct answer. 0.75. What is the ratio of the Exports (in Local Currency Unit) of 1960 in Canada to that in Chile?
Keep it short and to the point. 1.13e+04. What is the ratio of the Exports (in Local Currency Unit) of 1961 in Canada to that in Chile?
Offer a very short reply. 1.22e+04. What is the ratio of the Exports (in Local Currency Unit) of 1962 in Canada to that in Chile?
Keep it short and to the point. 1.14e+04. What is the ratio of the Exports (in Local Currency Unit) in 1963 in Canada to that in Chile?
Offer a very short reply. 7992.05. What is the ratio of the Exports (in Local Currency Unit) of 1960 in Central African Republic to that in Chad?
Make the answer very short. 0.62. What is the ratio of the Exports (in Local Currency Unit) of 1961 in Central African Republic to that in Chad?
Your response must be concise. 0.7. What is the ratio of the Exports (in Local Currency Unit) of 1962 in Central African Republic to that in Chad?
Give a very brief answer. 0.61. What is the ratio of the Exports (in Local Currency Unit) in 1963 in Central African Republic to that in Chad?
Offer a terse response. 0.68. What is the ratio of the Exports (in Local Currency Unit) in 1960 in Central African Republic to that in Chile?
Your answer should be very brief. 1.07e+04. What is the ratio of the Exports (in Local Currency Unit) in 1961 in Central African Republic to that in Chile?
Your response must be concise. 1.33e+04. What is the ratio of the Exports (in Local Currency Unit) in 1962 in Central African Republic to that in Chile?
Your response must be concise. 1.07e+04. What is the ratio of the Exports (in Local Currency Unit) in 1963 in Central African Republic to that in Chile?
Provide a succinct answer. 7272.73. What is the ratio of the Exports (in Local Currency Unit) in 1960 in Chad to that in Chile?
Offer a very short reply. 1.72e+04. What is the ratio of the Exports (in Local Currency Unit) of 1961 in Chad to that in Chile?
Ensure brevity in your answer.  1.90e+04. What is the ratio of the Exports (in Local Currency Unit) in 1962 in Chad to that in Chile?
Provide a succinct answer. 1.76e+04. What is the ratio of the Exports (in Local Currency Unit) of 1963 in Chad to that in Chile?
Make the answer very short. 1.07e+04. What is the difference between the highest and the second highest Exports (in Local Currency Unit) of 1960?
Make the answer very short. 3.53e+09. What is the difference between the highest and the second highest Exports (in Local Currency Unit) in 1961?
Provide a succinct answer. 3.39e+09. What is the difference between the highest and the second highest Exports (in Local Currency Unit) in 1962?
Make the answer very short. 4.32e+09. What is the difference between the highest and the second highest Exports (in Local Currency Unit) in 1963?
Make the answer very short. 3.00e+09. What is the difference between the highest and the lowest Exports (in Local Currency Unit) of 1960?
Your response must be concise. 1.03e+1. What is the difference between the highest and the lowest Exports (in Local Currency Unit) in 1961?
Offer a very short reply. 1.14e+1. What is the difference between the highest and the lowest Exports (in Local Currency Unit) of 1962?
Offer a very short reply. 1.23e+1. What is the difference between the highest and the lowest Exports (in Local Currency Unit) in 1963?
Keep it short and to the point. 1.18e+1. 